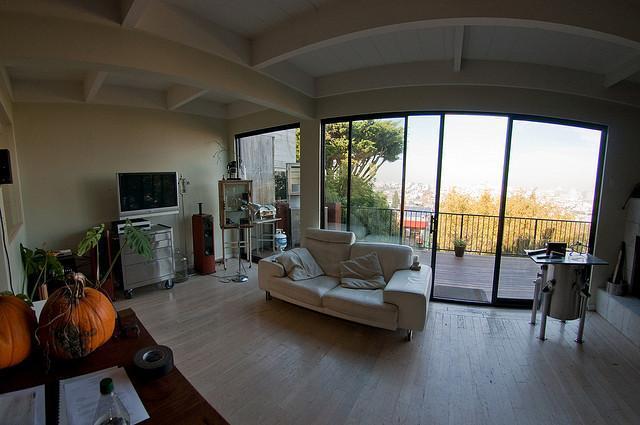How many pumpkins do you see?
Give a very brief answer. 2. How many people does that loveseat hold?
Give a very brief answer. 2. How many cars are parked?
Give a very brief answer. 0. 